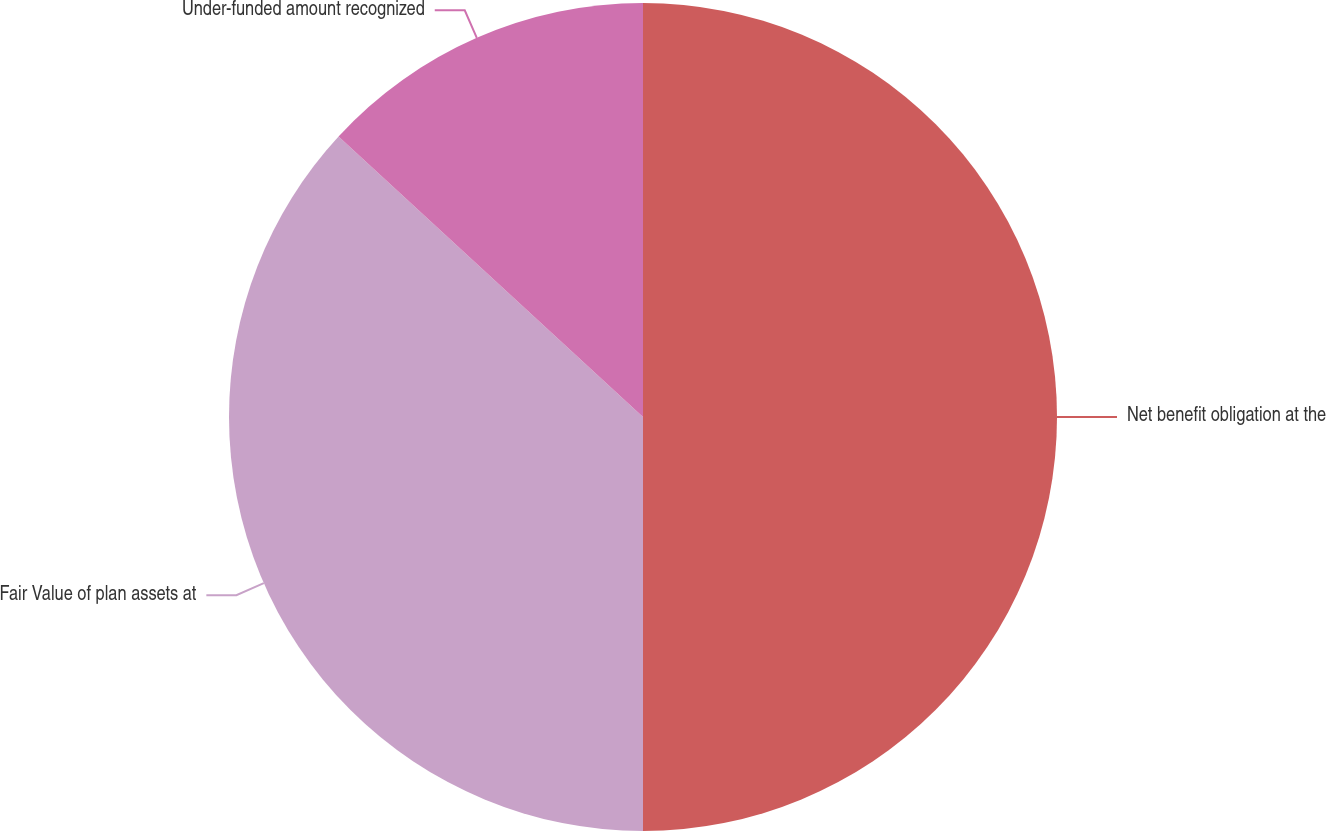<chart> <loc_0><loc_0><loc_500><loc_500><pie_chart><fcel>Net benefit obligation at the<fcel>Fair Value of plan assets at<fcel>Under-funded amount recognized<nl><fcel>50.0%<fcel>36.85%<fcel>13.15%<nl></chart> 